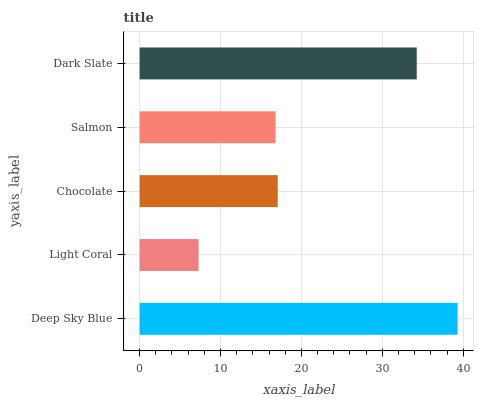Is Light Coral the minimum?
Answer yes or no. Yes. Is Deep Sky Blue the maximum?
Answer yes or no. Yes. Is Chocolate the minimum?
Answer yes or no. No. Is Chocolate the maximum?
Answer yes or no. No. Is Chocolate greater than Light Coral?
Answer yes or no. Yes. Is Light Coral less than Chocolate?
Answer yes or no. Yes. Is Light Coral greater than Chocolate?
Answer yes or no. No. Is Chocolate less than Light Coral?
Answer yes or no. No. Is Chocolate the high median?
Answer yes or no. Yes. Is Chocolate the low median?
Answer yes or no. Yes. Is Salmon the high median?
Answer yes or no. No. Is Deep Sky Blue the low median?
Answer yes or no. No. 